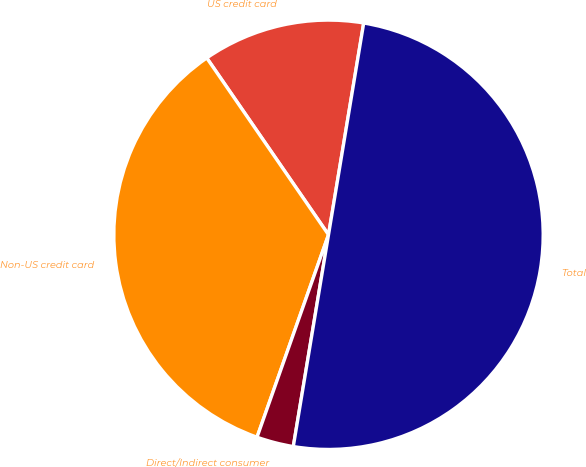Convert chart. <chart><loc_0><loc_0><loc_500><loc_500><pie_chart><fcel>US credit card<fcel>Non-US credit card<fcel>Direct/Indirect consumer<fcel>Total<nl><fcel>12.22%<fcel>35.0%<fcel>2.78%<fcel>50.0%<nl></chart> 